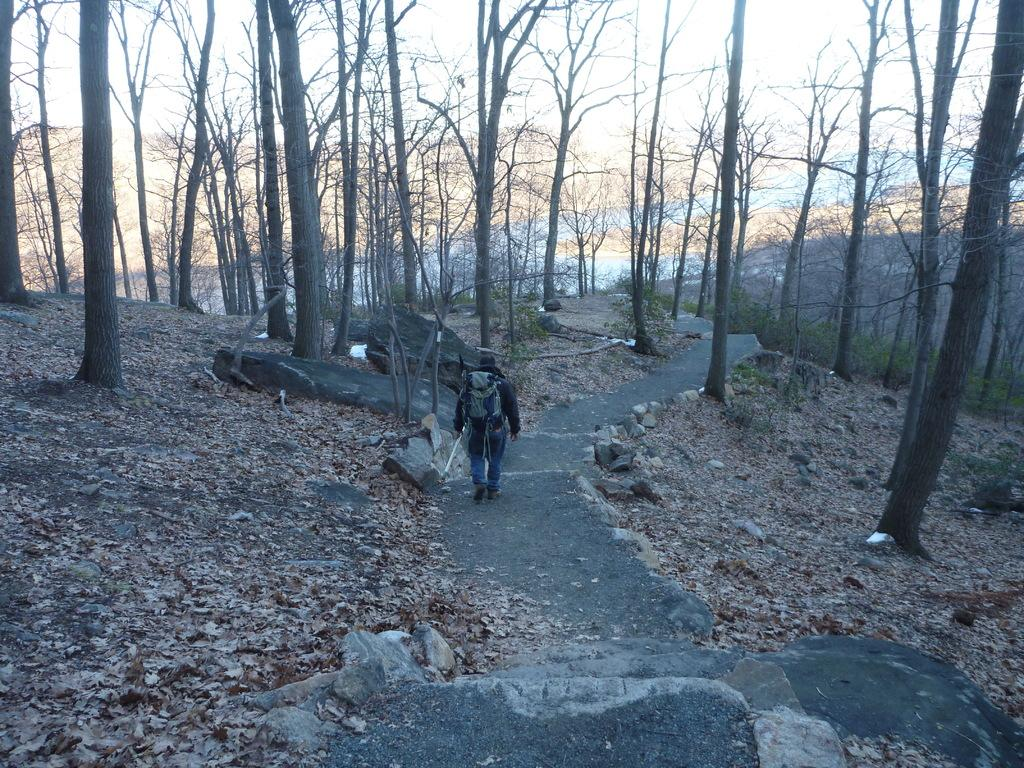What is the main subject of the image? There is a man in the image. What is the man doing in the image? The man is walking in the image. What is the man carrying while walking? The man is carrying a bag in the image. What is the man holding in addition to the bag? The man is holding a stick in the image. What type of natural elements can be seen in the image? Leaves, stones, and trees are visible in the image. What is visible in the background of the image? The sky is visible in the background of the image. What day is it in the image? The provided facts do not mention the day, so it cannot be determined from the image. 